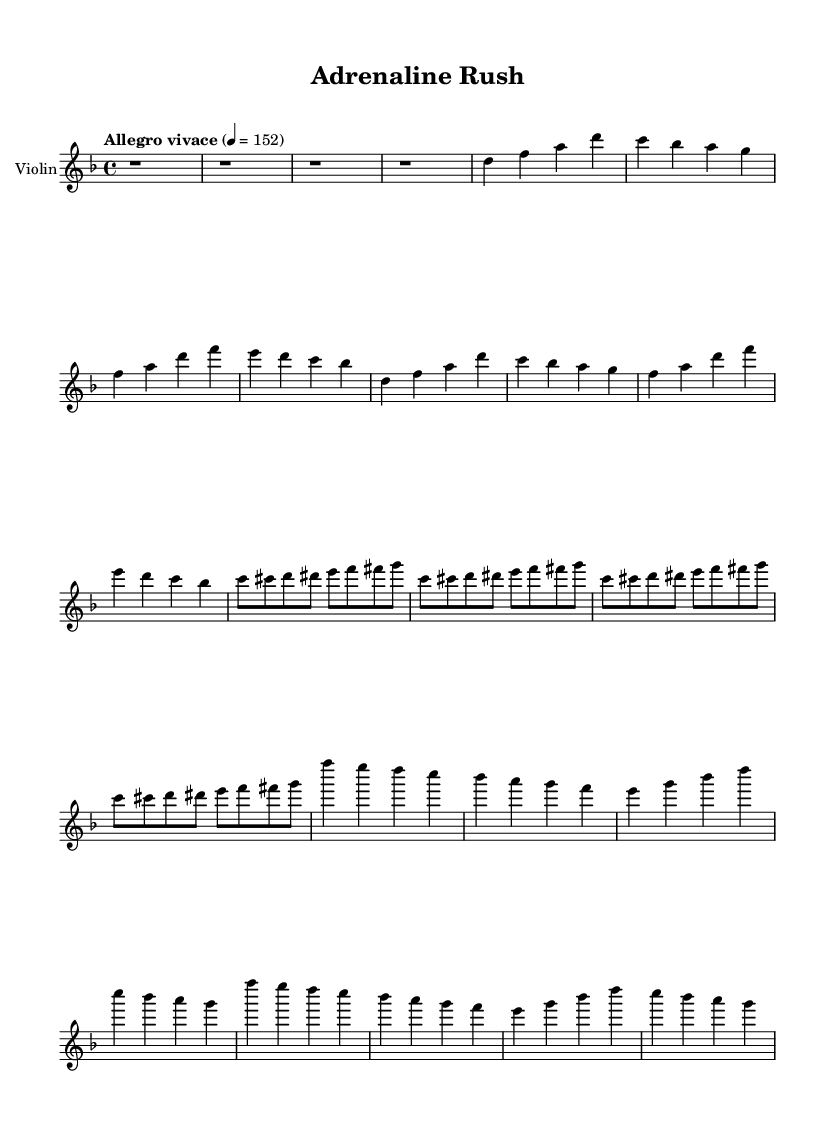What is the key signature of this music? The key signature is indicated by the number of sharps or flats at the beginning of the staff. In this piece, no sharps or flats are shown meaning it is in D minor.
Answer: D minor What is the time signature? The time signature is shown at the beginning of the staff after the clef and key signature. It shows that there are four beats in each measure, represented by the '4/4' notation.
Answer: 4/4 What is the tempo marking of the piece? The tempo marking is found at the beginning of the score and gives the speed indication. In this case, "Allegro vivace" suggests a quick and lively tempo.
Answer: Allegro vivace What instruments are used in this piece? The title above the staff indicates that the piece is written for a single instrument, which in this case is the violin.
Answer: Violin How many measures are in the main theme (A) section? The main theme (A) is outlined in the first section of the piece, consisting of 8 measures as indicated by counting each grouping of notes separated by the bar lines.
Answer: 8 What is the main note of the bridge section? The bridge section features a repeated pattern of notes, starting on ‘c’ for the first note in the sequence of the eighth notes. This establishes ‘c’ prominently in that segment.
Answer: c What type of music evokes high-speed chases in this piece? The rapid tempo and the energetic main themes create a thrilling atmosphere typical of high-speed chases. The combination of quick rhythms and dynamic intervals adds to the cinematic feel.
Answer: Cinematic 